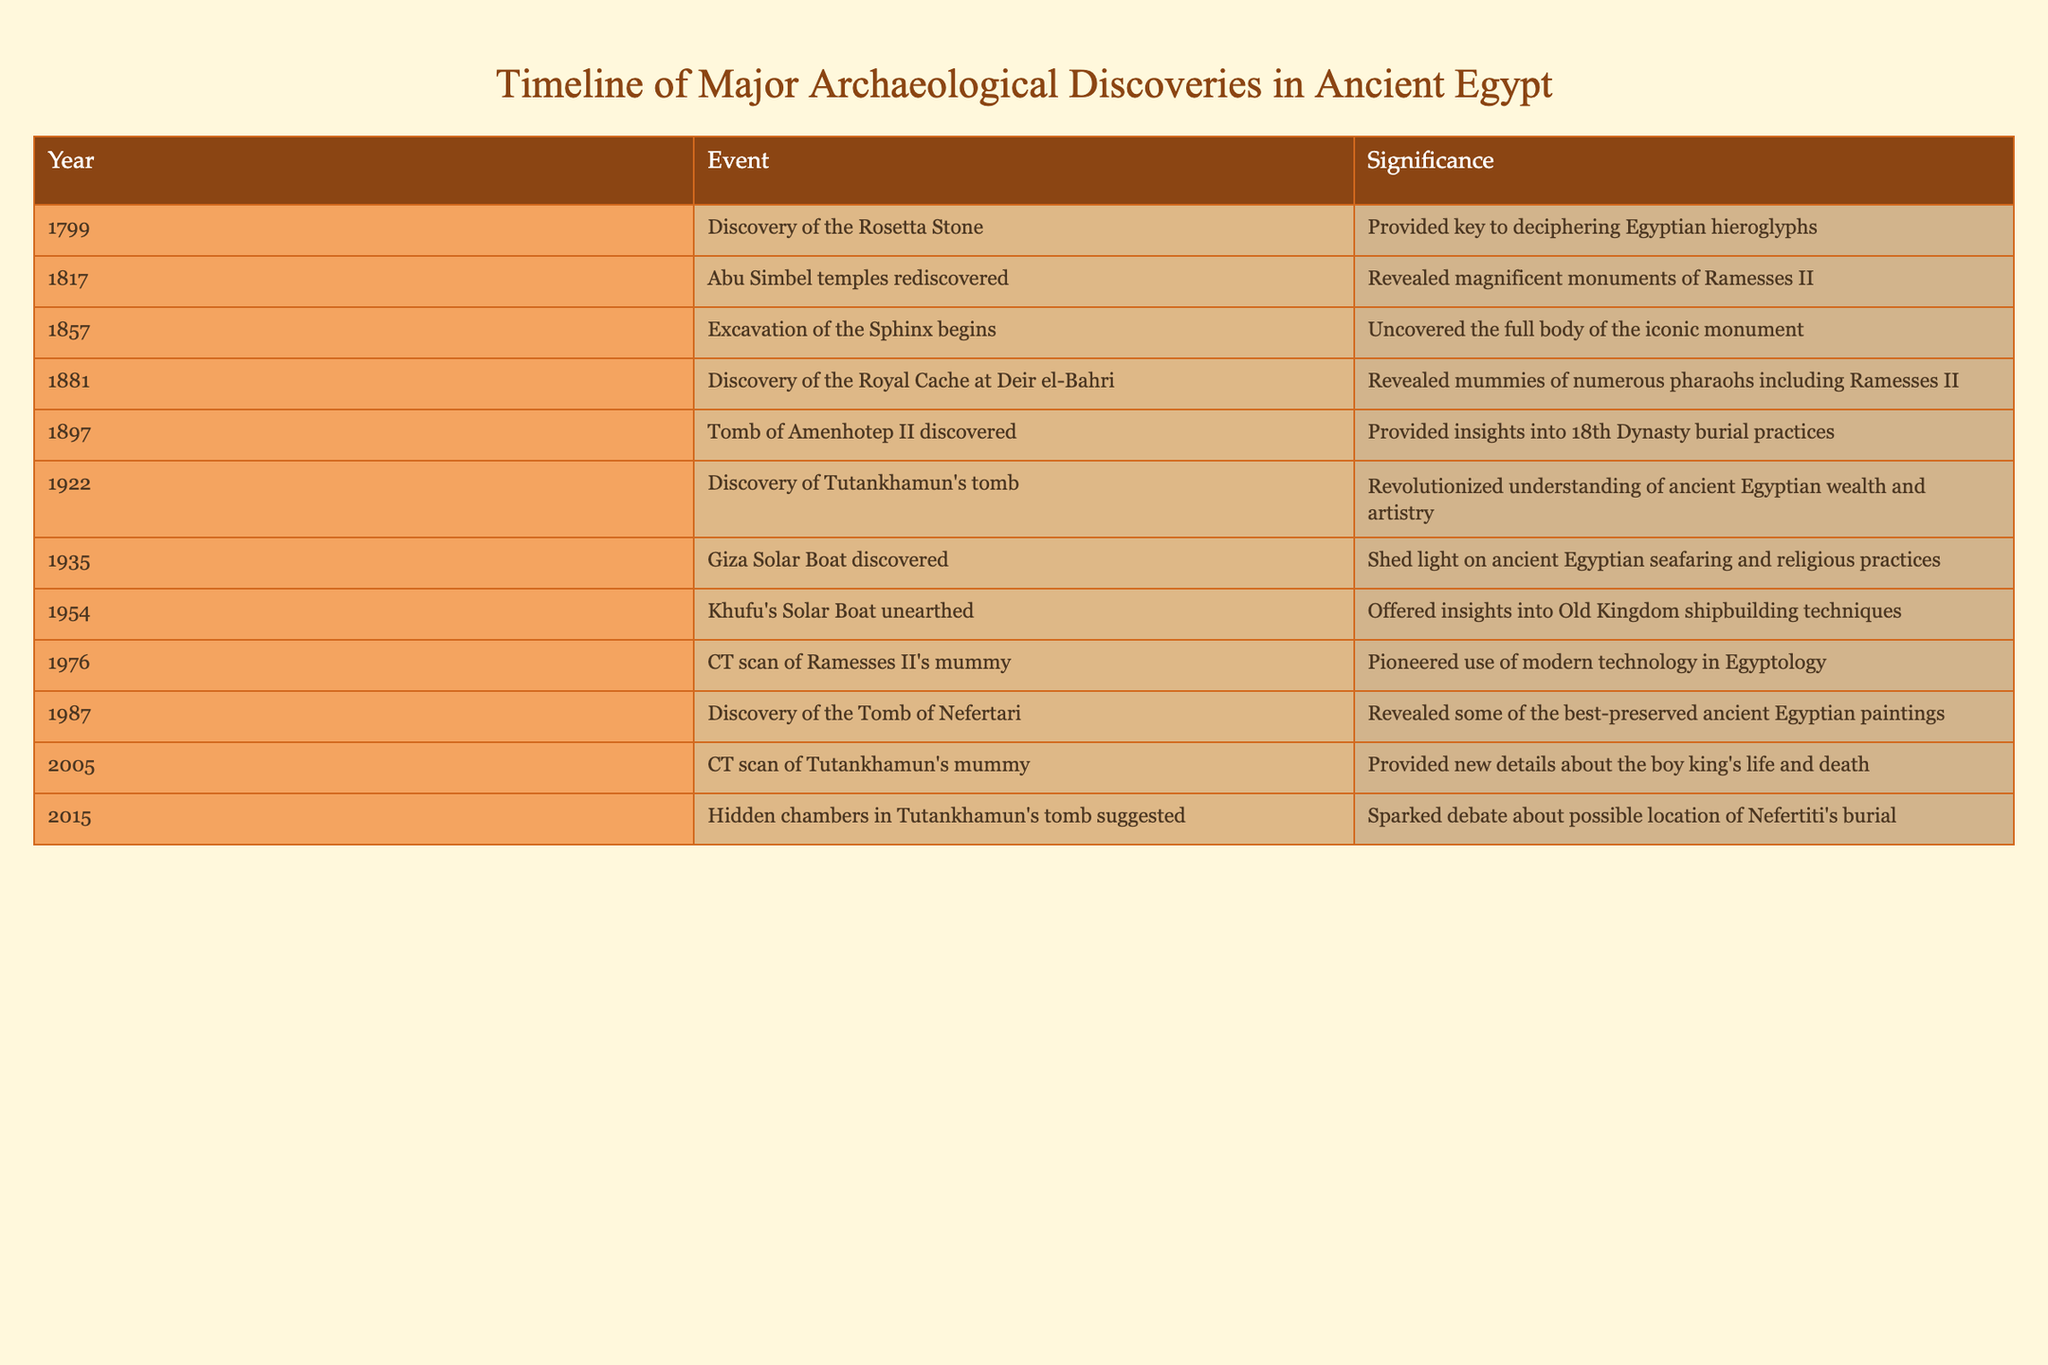What year was the discovery of the Rosetta Stone? The table indicates that the Rosetta Stone was discovered in 1799. This is a specific event that can be retrieved directly from the table without any additional calculations.
Answer: 1799 What significance does the discovery of Tutankhamun's tomb hold? According to the table, the significance of discovering Tutankhamun's tomb in 1922 is that it revolutionized the understanding of ancient Egyptian wealth and artistry. This can be directly referenced from the significance column corresponding to that year.
Answer: Revolutionized understanding of ancient Egyptian wealth and artistry Which two discoveries were made in the 1980s, and what were their significances? The discoveries made in the 1980s are the discovery of the Tomb of Nefertari in 1987 and the CT scan of Ramesses II's mummy in 1976. The significance of the Tomb of Nefertari is that it revealed some of the best-preserved ancient Egyptian paintings, while the significance of the CT scan is that it pioneered the use of modern technology in Egyptology. This requires pulling information from multiple entries and then stating their significances.
Answer: Tomb of Nefertari (1987): Revealed best-preserved paintings; CT scan of Ramesses II's mummy (1976): Pioneered modern technology in Egyptology How many major archaeological discoveries are listed in this timeline? By counting each unique event in the table, we find that there are 12 entries listed, from the discovery of the Rosetta Stone in 1799 to the suggestion of hidden chambers in Tutankhamun's tomb in 2015. This requires tallying each year listed.
Answer: 12 Is it true that the excavation of the Sphinx began before the discovery of Tutankhamun's tomb? Yes, based on the timeline in the table, the excavation of the Sphinx began in 1857, and the discovery of Tutankhamun's tomb occurred in 1922. This is a factual comparison that can be derived from their respective years listed.
Answer: Yes What is the average year of the discoveries made in the 20th century (1900-1999)? The discoveries made in the 20th century according to the data are the discovery of Tutankhamun's tomb in 1922, the Giza Solar Boat in 1935, Khufu's Solar Boat in 1954, the CT scan of Ramesses II's mummy in 1976, and the discovery of the Tomb of Nefertari in 1987. To find the average, sum these years (1922 + 1935 + 1954 + 1976 + 1987 = 9724) and divide by the number of discoveries (5), yielding an average year of approximately 1944.8.
Answer: 1945 What major discovery occurred closest to the end of the 20th century? Reviewing the years of each discovery, the last significant event listed that occurred before the 21st century is the discovery of the Tomb of Nefertari in 1987. This means counting backwards from the end of the century to find the most recent entry.
Answer: Discovery of the Tomb of Nefertari in 1987 When was the Giza Solar Boat discovered, and what does it reveal about ancient Egyptian practices? The Giza Solar Boat was discovered in 1935, according to the table. It reveals insights into ancient Egyptian seafaring and religious practices, which can be found in the significance column associated with that year. This requires retrieving both the year and significance together.
Answer: 1935; Insights into ancient Egyptian seafaring and religious practices 